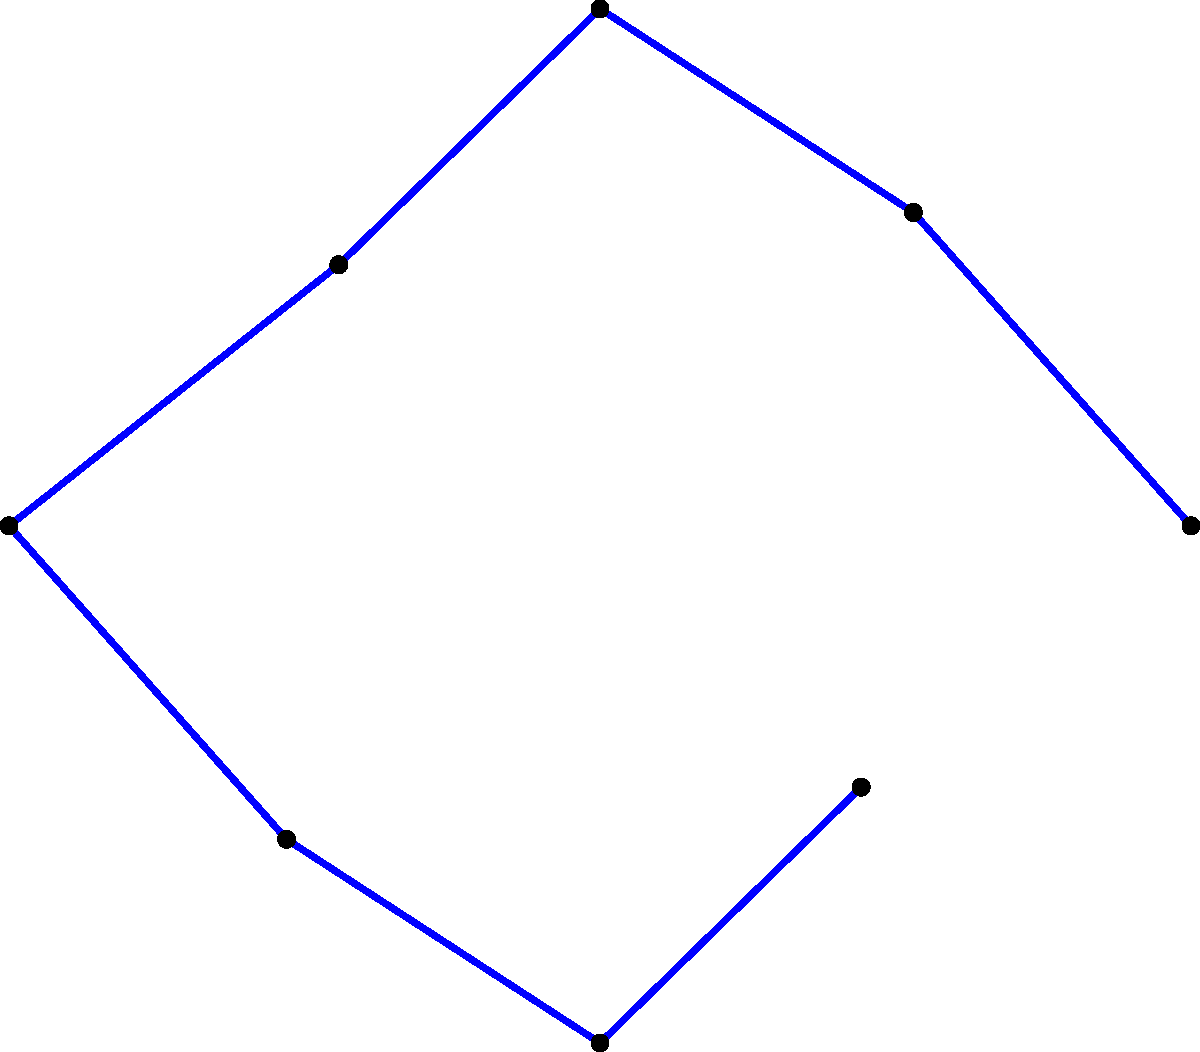In a rugby scrum, the force distribution among the players is represented by the polar graph above. Each point represents a player's position, and the distance from the center indicates the force they exert. If the total force in the scrum is 100 units, what is the approximate force exerted by player 4? To solve this problem, we need to follow these steps:

1. Observe that there are 8 players in the scrum formation.

2. The force exerted by each player is proportional to their distance from the center in the polar graph.

3. To find the total distance (which represents the total force), we sum up all the radial distances:
   $$(8 + 6 + 7 + 5 + 8 + 6 + 7 + 5) = 52$$

4. We know that this total distance of 52 units represents a total force of 100 units.

5. To find the force per unit of distance, we divide:
   $$\frac{100 \text{ units of force}}{52 \text{ units of distance}} \approx 1.92 \text{ force units per distance unit}$$

6. Player 4 is represented by the point at 3π/4 radians, with a distance of 5 units from the center.

7. To find player 4's force, we multiply their distance by the force per unit distance:
   $$5 \times 1.92 \approx 9.6 \text{ units of force}$$

Therefore, player 4 exerts approximately 9.6 units of force in the scrum.
Answer: 9.6 units 